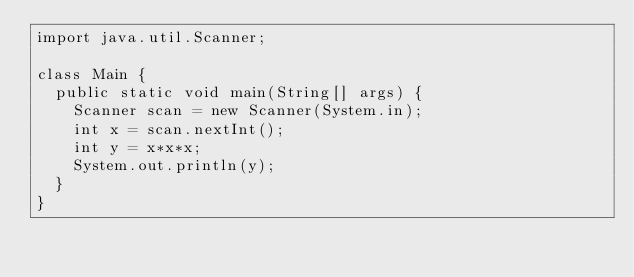Convert code to text. <code><loc_0><loc_0><loc_500><loc_500><_Java_>import java.util.Scanner;
 
class Main {
  public static void main(String[] args) {
    Scanner scan = new Scanner(System.in);
    int x = scan.nextInt();
    int y = x*x*x;
    System.out.println(y);
  }
}
</code> 